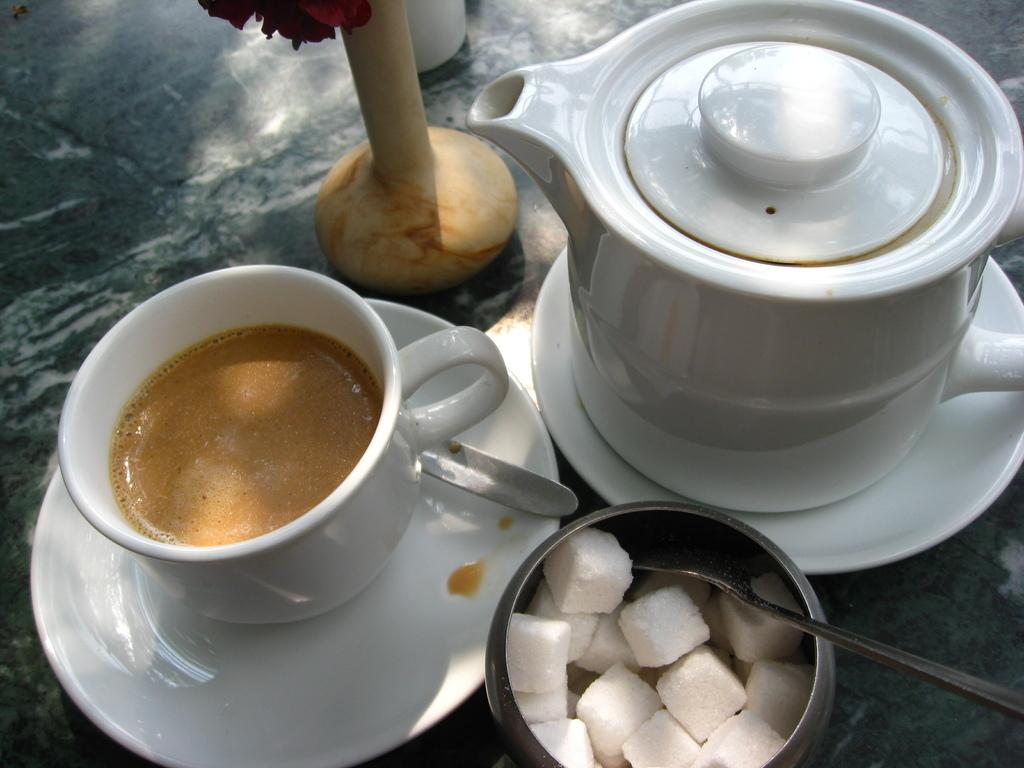What objects are present in the image that are used for eating? In the image, there are bowls and spoons that are used for eating. What other object can be seen on the table in the image? There is a flower vase on the table in the image. Where are the bowls, spoons, and flower vase located in the image? These objects are placed on a table in the image. What type of butter is being used to burn in the image? There is no butter or any indication of burning in the image. 